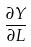Convert formula to latex. <formula><loc_0><loc_0><loc_500><loc_500>\frac { \partial Y } { \partial L }</formula> 